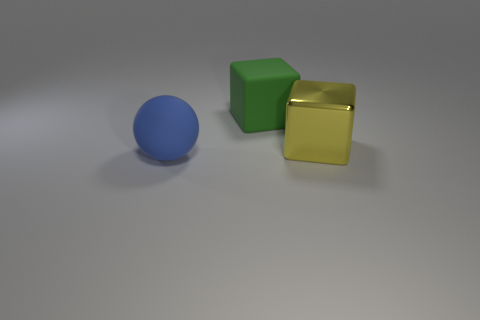There is a big rubber object that is left of the large green rubber thing; is it the same color as the object that is behind the yellow metal object?
Give a very brief answer. No. There is a rubber ball that is the same size as the yellow block; what color is it?
Your response must be concise. Blue. Are there any objects that have the same color as the sphere?
Offer a terse response. No. There is a rubber thing that is in front of the yellow shiny cube; does it have the same size as the large yellow metal thing?
Your answer should be compact. Yes. Are there an equal number of blue rubber balls in front of the blue rubber thing and big purple balls?
Offer a terse response. Yes. How many objects are either cubes that are behind the big shiny cube or green rubber cubes?
Your answer should be compact. 1. What is the shape of the big thing that is on the right side of the large matte ball and left of the yellow thing?
Keep it short and to the point. Cube. What number of things are either big objects that are to the left of the metal cube or yellow cubes that are to the right of the large blue matte sphere?
Provide a succinct answer. 3. What number of other things are there of the same size as the matte block?
Provide a succinct answer. 2. Does the matte thing in front of the large yellow cube have the same color as the large shiny cube?
Give a very brief answer. No. 